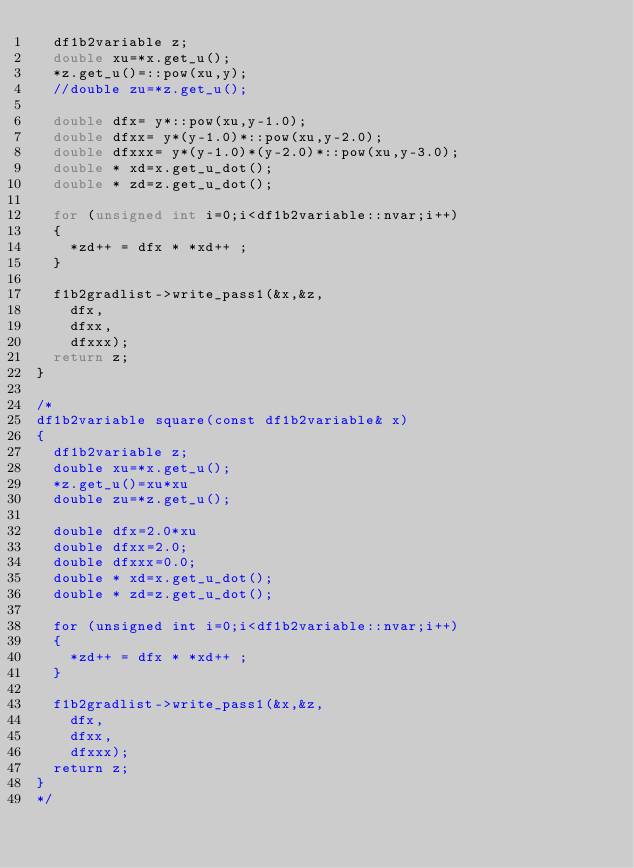<code> <loc_0><loc_0><loc_500><loc_500><_C++_>  df1b2variable z;
  double xu=*x.get_u();
  *z.get_u()=::pow(xu,y);
  //double zu=*z.get_u();

  double dfx= y*::pow(xu,y-1.0);
  double dfxx= y*(y-1.0)*::pow(xu,y-2.0);
  double dfxxx= y*(y-1.0)*(y-2.0)*::pow(xu,y-3.0);
  double * xd=x.get_u_dot();
  double * zd=z.get_u_dot();

  for (unsigned int i=0;i<df1b2variable::nvar;i++)
  {
    *zd++ = dfx * *xd++ ;
  }

  f1b2gradlist->write_pass1(&x,&z,
    dfx,
    dfxx,
    dfxxx);
  return z;
}

/*
df1b2variable square(const df1b2variable& x)
{
  df1b2variable z;
  double xu=*x.get_u();
  *z.get_u()=xu*xu
  double zu=*z.get_u();

  double dfx=2.0*xu
  double dfxx=2.0;
  double dfxxx=0.0;
  double * xd=x.get_u_dot();
  double * zd=z.get_u_dot();

  for (unsigned int i=0;i<df1b2variable::nvar;i++)
  {
    *zd++ = dfx * *xd++ ;
  }

  f1b2gradlist->write_pass1(&x,&z,
    dfx,
    dfxx,
    dfxxx);
  return z;
}
*/
</code> 